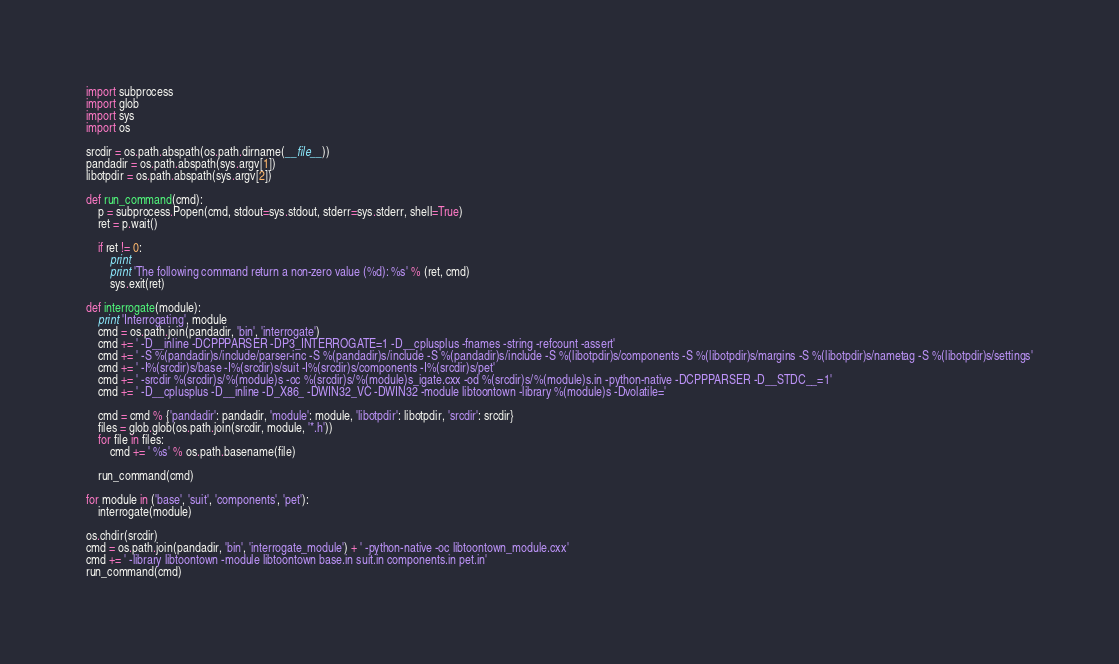<code> <loc_0><loc_0><loc_500><loc_500><_Python_>import subprocess
import glob
import sys
import os

srcdir = os.path.abspath(os.path.dirname(__file__))
pandadir = os.path.abspath(sys.argv[1])
libotpdir = os.path.abspath(sys.argv[2])

def run_command(cmd):
    p = subprocess.Popen(cmd, stdout=sys.stdout, stderr=sys.stderr, shell=True)
    ret = p.wait()

    if ret != 0:
        print
        print 'The following command return a non-zero value (%d): %s' % (ret, cmd)
        sys.exit(ret)

def interrogate(module):
    print 'Interrogating', module
    cmd = os.path.join(pandadir, 'bin', 'interrogate')
    cmd += ' -D__inline -DCPPPARSER -DP3_INTERROGATE=1 -D__cplusplus -fnames -string -refcount -assert'
    cmd += ' -S %(pandadir)s/include/parser-inc -S %(pandadir)s/include -S %(pandadir)s/include -S %(libotpdir)s/components -S %(libotpdir)s/margins -S %(libotpdir)s/nametag -S %(libotpdir)s/settings'
    cmd += ' -I%(srcdir)s/base -I%(srcdir)s/suit -I%(srcdir)s/components -I%(srcdir)s/pet' 
    cmd += ' -srcdir %(srcdir)s/%(module)s -oc %(srcdir)s/%(module)s_igate.cxx -od %(srcdir)s/%(module)s.in -python-native -DCPPPARSER -D__STDC__=1'
    cmd += ' -D__cplusplus -D__inline -D_X86_ -DWIN32_VC -DWIN32 -module libtoontown -library %(module)s -Dvolatile='

    cmd = cmd % {'pandadir': pandadir, 'module': module, 'libotpdir': libotpdir, 'srcdir': srcdir}
    files = glob.glob(os.path.join(srcdir, module, '*.h'))
    for file in files:
        cmd += ' %s' % os.path.basename(file)

    run_command(cmd)

for module in ('base', 'suit', 'components', 'pet'):
    interrogate(module)

os.chdir(srcdir)
cmd = os.path.join(pandadir, 'bin', 'interrogate_module') + ' -python-native -oc libtoontown_module.cxx'
cmd += ' -library libtoontown -module libtoontown base.in suit.in components.in pet.in'
run_command(cmd)
</code> 